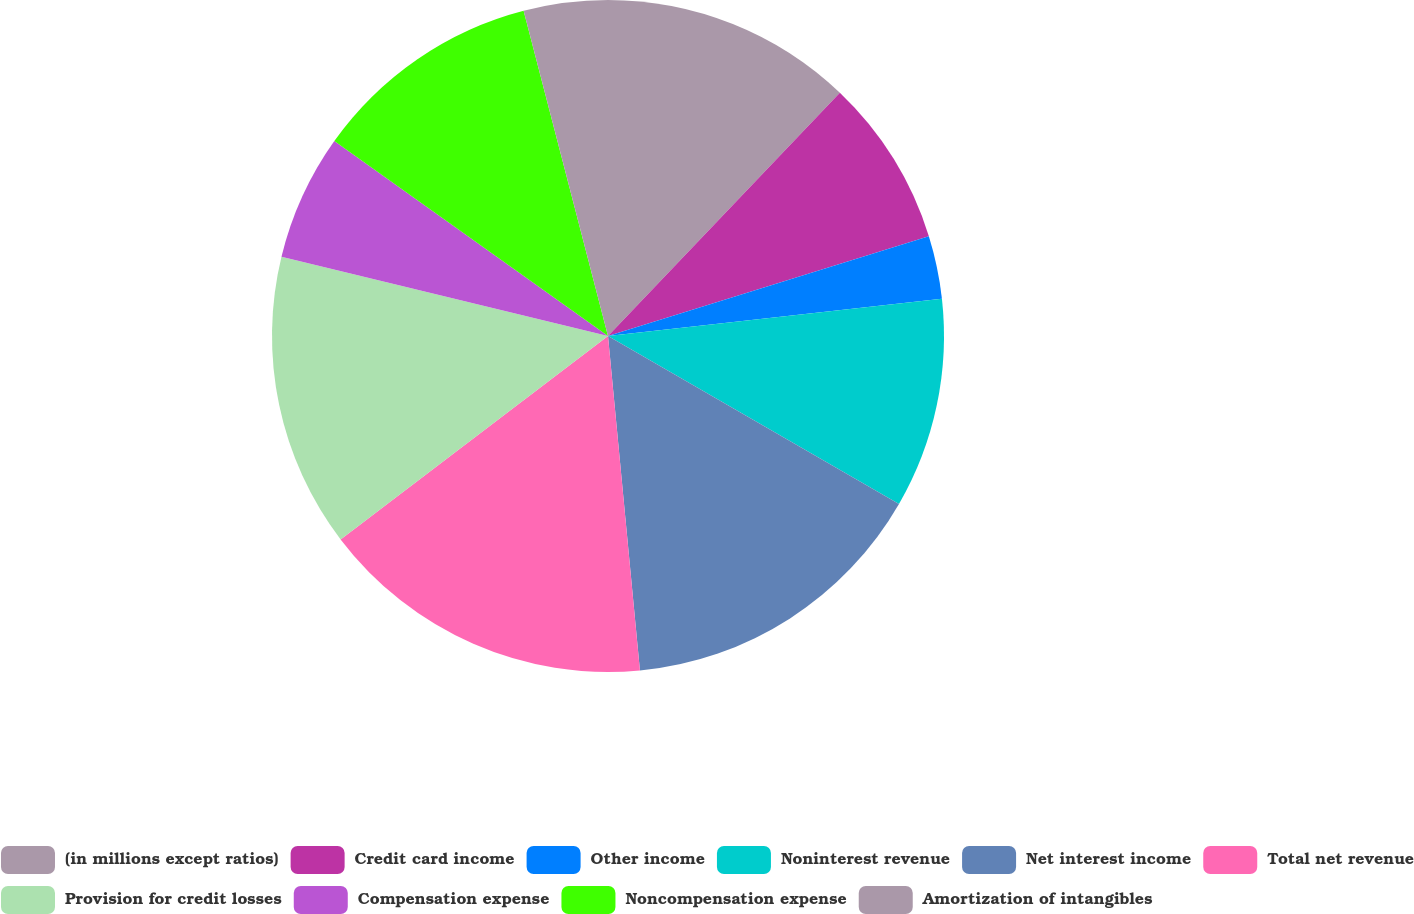Convert chart. <chart><loc_0><loc_0><loc_500><loc_500><pie_chart><fcel>(in millions except ratios)<fcel>Credit card income<fcel>Other income<fcel>Noninterest revenue<fcel>Net interest income<fcel>Total net revenue<fcel>Provision for credit losses<fcel>Compensation expense<fcel>Noncompensation expense<fcel>Amortization of intangibles<nl><fcel>12.12%<fcel>8.08%<fcel>3.03%<fcel>10.1%<fcel>15.15%<fcel>16.16%<fcel>14.14%<fcel>6.06%<fcel>11.11%<fcel>4.04%<nl></chart> 